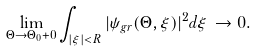Convert formula to latex. <formula><loc_0><loc_0><loc_500><loc_500>\lim _ { \Theta \to \Theta _ { 0 } + 0 } \int _ { | \xi | < R } | \psi _ { g r } ( \Theta , \xi ) | ^ { 2 } d \xi \, \to 0 .</formula> 